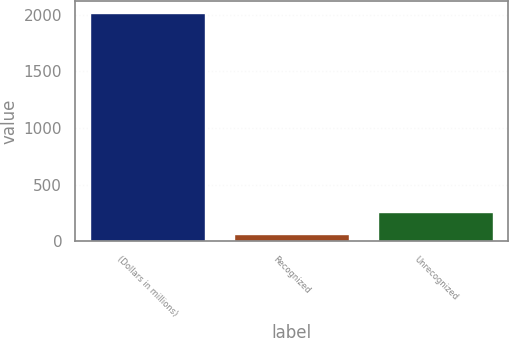Convert chart to OTSL. <chart><loc_0><loc_0><loc_500><loc_500><bar_chart><fcel>(Dollars in millions)<fcel>Recognized<fcel>Unrecognized<nl><fcel>2018<fcel>61<fcel>256.7<nl></chart> 